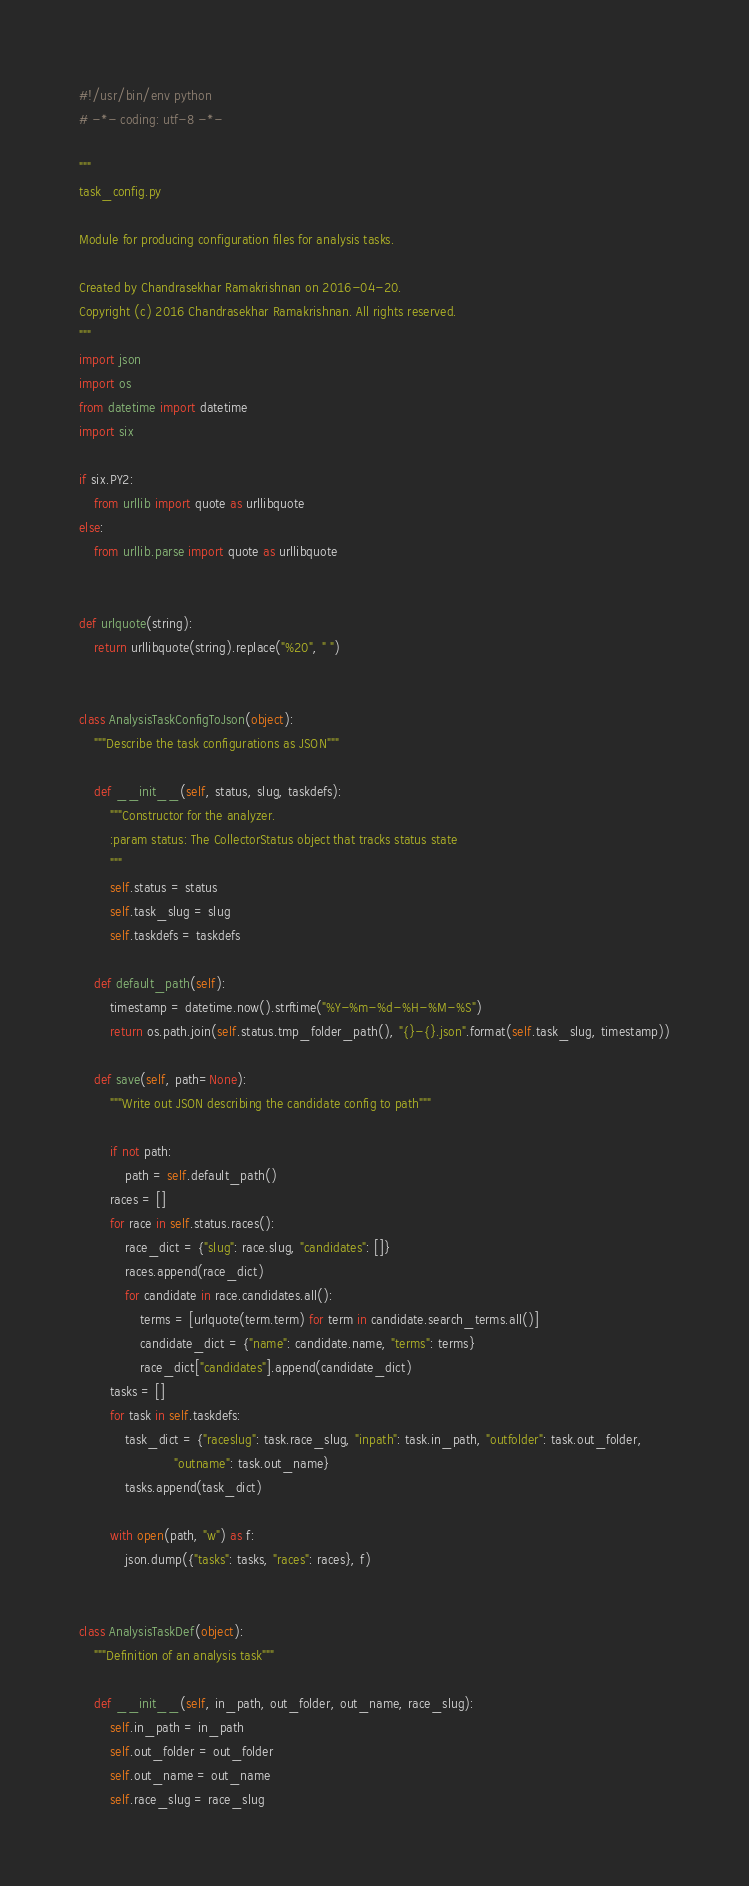<code> <loc_0><loc_0><loc_500><loc_500><_Python_>#!/usr/bin/env python
# -*- coding: utf-8 -*-

"""
task_config.py

Module for producing configuration files for analysis tasks.

Created by Chandrasekhar Ramakrishnan on 2016-04-20.
Copyright (c) 2016 Chandrasekhar Ramakrishnan. All rights reserved.
"""
import json
import os
from datetime import datetime
import six

if six.PY2:
    from urllib import quote as urllibquote
else:
    from urllib.parse import quote as urllibquote


def urlquote(string):
    return urllibquote(string).replace("%20", " ")


class AnalysisTaskConfigToJson(object):
    """Describe the task configurations as JSON"""

    def __init__(self, status, slug, taskdefs):
        """Constructor for the analyzer.
        :param status: The CollectorStatus object that tracks status state
        """
        self.status = status
        self.task_slug = slug
        self.taskdefs = taskdefs

    def default_path(self):
        timestamp = datetime.now().strftime("%Y-%m-%d-%H-%M-%S")
        return os.path.join(self.status.tmp_folder_path(), "{}-{}.json".format(self.task_slug, timestamp))

    def save(self, path=None):
        """Write out JSON describing the candidate config to path"""

        if not path:
            path = self.default_path()
        races = []
        for race in self.status.races():
            race_dict = {"slug": race.slug, "candidates": []}
            races.append(race_dict)
            for candidate in race.candidates.all():
                terms = [urlquote(term.term) for term in candidate.search_terms.all()]
                candidate_dict = {"name": candidate.name, "terms": terms}
                race_dict["candidates"].append(candidate_dict)
        tasks = []
        for task in self.taskdefs:
            task_dict = {"raceslug": task.race_slug, "inpath": task.in_path, "outfolder": task.out_folder,
                         "outname": task.out_name}
            tasks.append(task_dict)

        with open(path, "w") as f:
            json.dump({"tasks": tasks, "races": races}, f)


class AnalysisTaskDef(object):
    """Definition of an analysis task"""

    def __init__(self, in_path, out_folder, out_name, race_slug):
        self.in_path = in_path
        self.out_folder = out_folder
        self.out_name = out_name
        self.race_slug = race_slug
</code> 